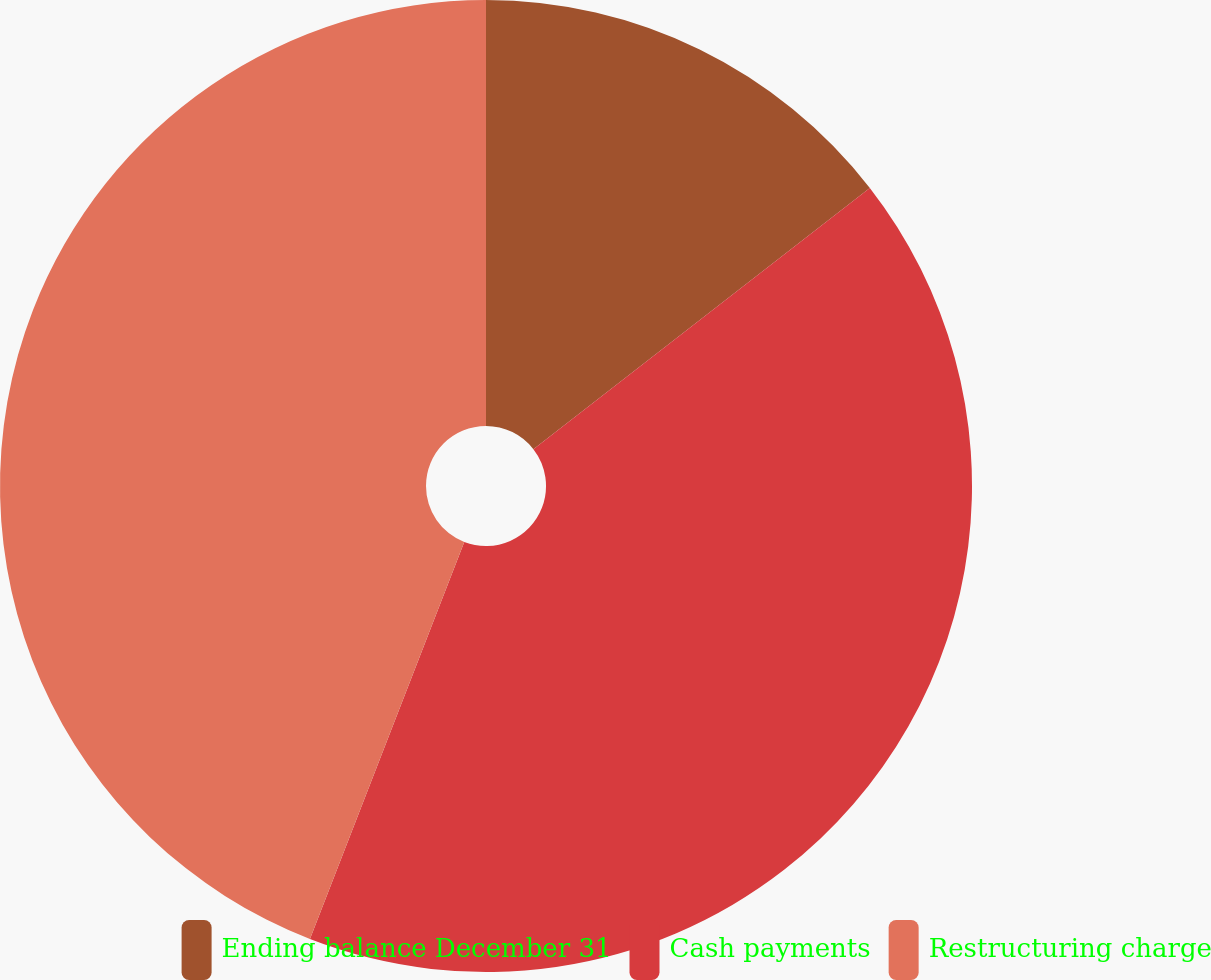Convert chart to OTSL. <chart><loc_0><loc_0><loc_500><loc_500><pie_chart><fcel>Ending balance December 31<fcel>Cash payments<fcel>Restructuring charge<nl><fcel>14.49%<fcel>41.41%<fcel>44.1%<nl></chart> 